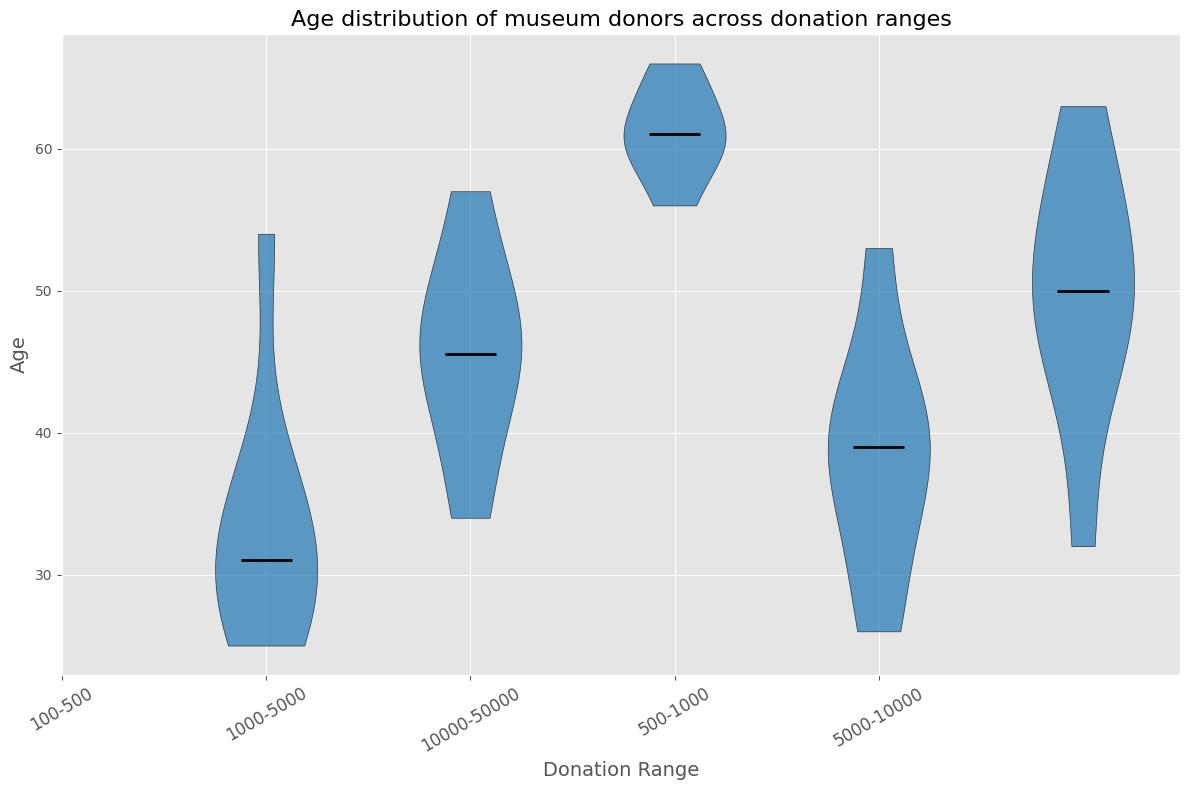What's the median age of donors in the "100-500" donation range? By looking at the position of the median line inside the corresponding violin plot for the "100-500" donation range, we can determine that the median age is around 30.
Answer: 30 Which donation range has the highest median age for donors? By comparing the position of the median lines in each violin plot, we can observe that the "10000-50000" donation range has the highest median age, around 60.
Answer: 10000-50000 How does the age distribution in the "1000-5000" donation range compare to the "500-1000" range? The median age seems to be higher in the "1000-5000" range compared to the "500-1000" range. Additionally, the age distribution in the "1000-5000" appears more spread out, indicating more variability in ages.
Answer: Higher median and more spread out What is the range of ages for donors in the "5000-10000" donation range? By looking at the spread of the violin plot for the "5000-10000" range, we can see that the ages range from around mid-40s to late 50s.
Answer: Mid-40s to late 50s Which donation range shows the widest variation in donor ages? By examining the width and length of each violin plot, the "100-500" donation range shows the widest variation with donor ages spanning roughly from mid-20s to mid-50s.
Answer: 100-500 Do older donors tend to donate in higher ranges? By observing the general trend in the violin plots, we can see that higher donation ranges, such as "10000-50000", are associated with older donors, indicating a possible trend where older donors tend to donate more.
Answer: Yes Is there any donation range where the age distribution is relatively uniform? By inspecting the shapes of the violin plots, we see that the "500-1000" range has a relatively uniform distribution without significant peaks, indicating a consistent spread of donor ages.
Answer: 500-1000 Which donation range has the youngest median donor age? By comparing the position of the median lines, the "100-500" donation range has the youngest median donor age, around 30.
Answer: 100-500 